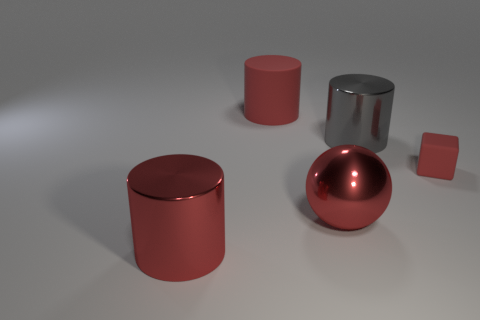What number of large cylinders have the same color as the big shiny ball?
Your answer should be compact. 2. Does the gray thing have the same shape as the large rubber object?
Ensure brevity in your answer.  Yes. What size is the thing that is to the right of the gray shiny cylinder?
Give a very brief answer. Small. What is the size of the thing that is made of the same material as the cube?
Give a very brief answer. Large. Are there fewer red shiny spheres than large purple rubber cubes?
Your response must be concise. No. What is the material of the gray thing that is the same size as the metallic sphere?
Provide a succinct answer. Metal. Are there more small red blocks than big red cylinders?
Your answer should be very brief. No. What number of other things are there of the same color as the small thing?
Provide a short and direct response. 3. How many red things are right of the big gray object and in front of the small rubber thing?
Ensure brevity in your answer.  0. Are there any other things that have the same size as the red cube?
Provide a succinct answer. No. 